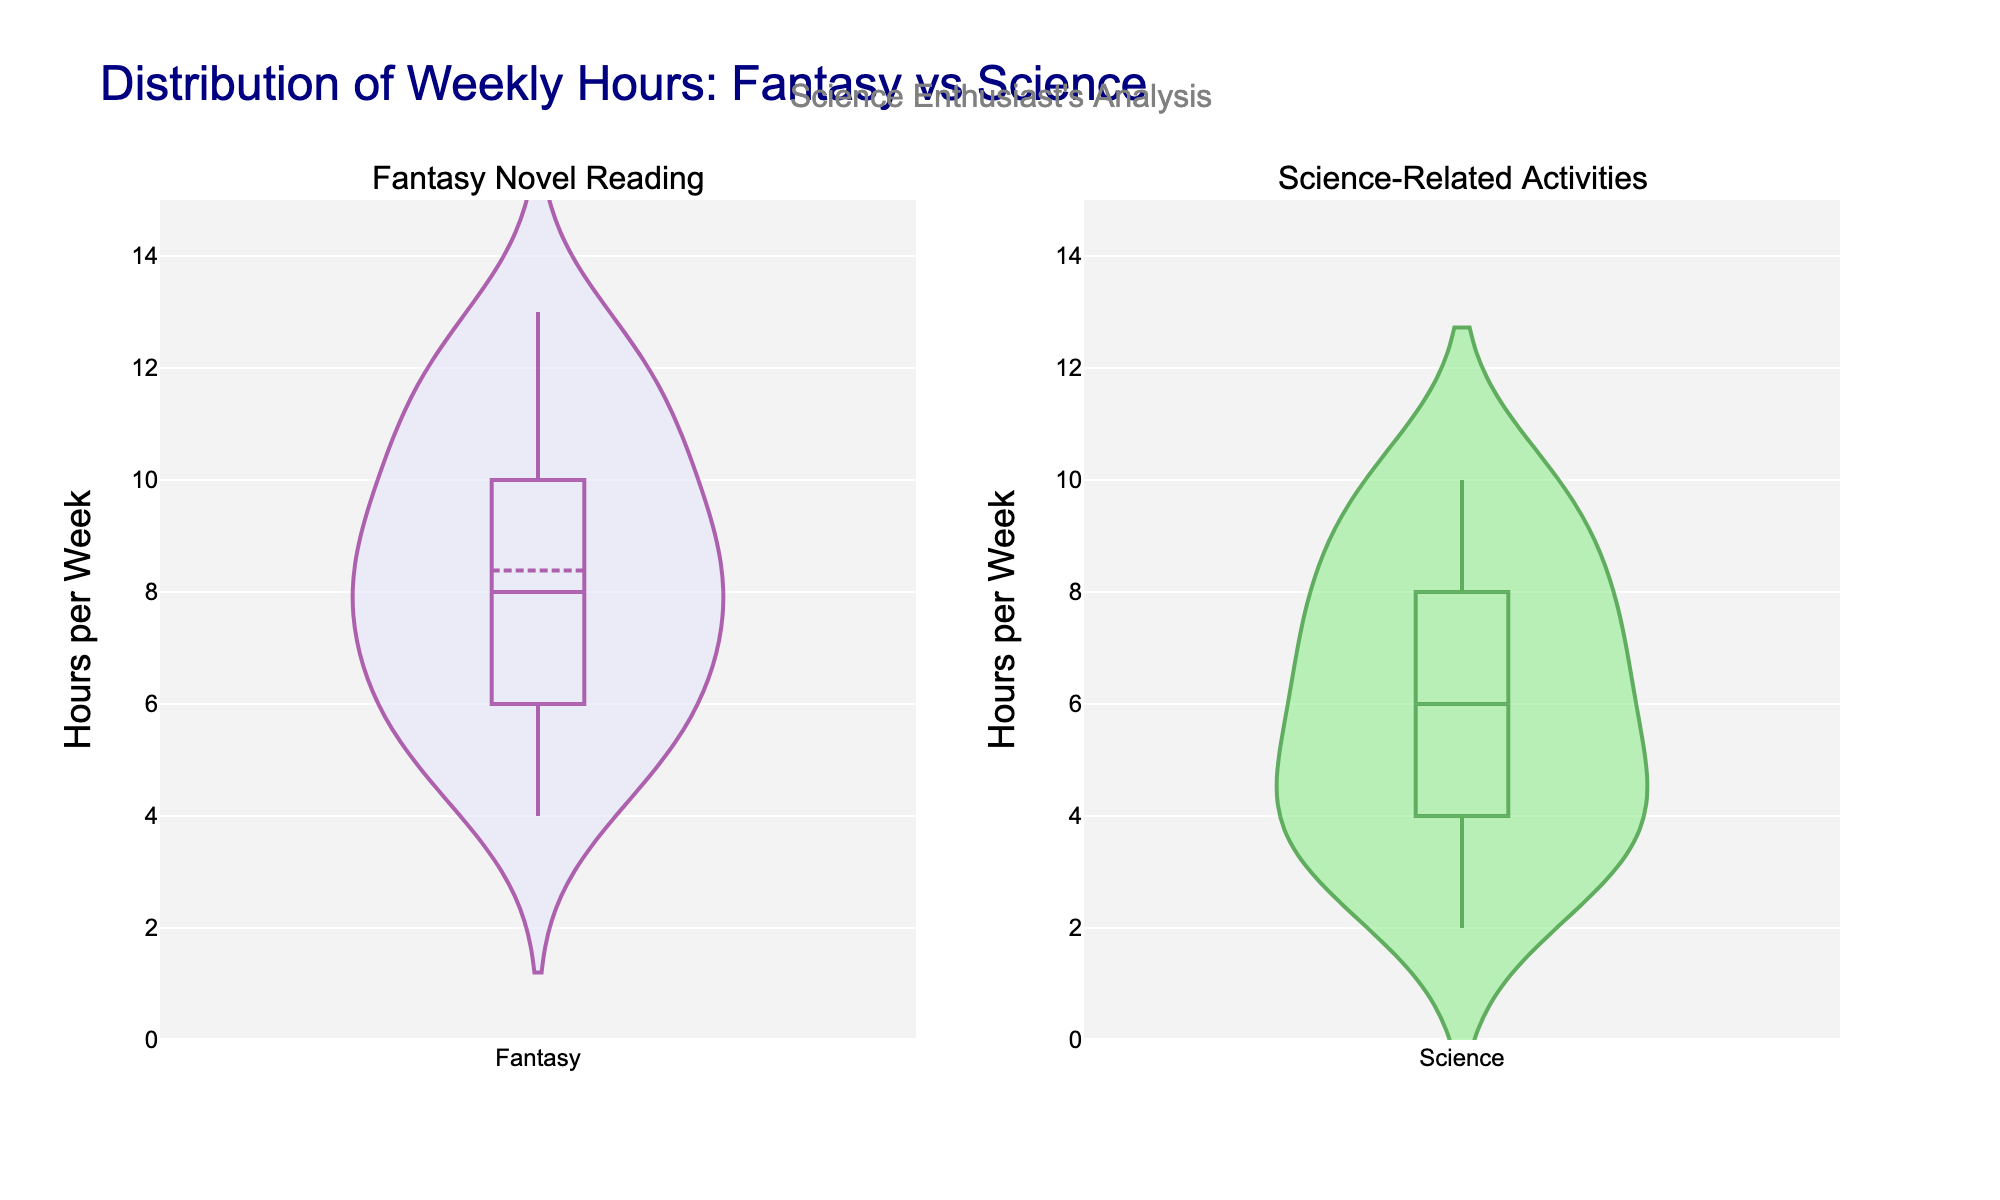What is the title of the figure? The title of the figure is located at the top of the plot and summarizes the overall content of the figure.
Answer: Distribution of Weekly Hours: Fantasy vs Science What do the colors represent on the violin plots? The colors differentiate the two categories being compared. The purple color represents Fantasy Novel Reading, and the green color represents Science-Related Activities.
Answer: Fantasy is purple, Science is green How many hours per week do most students spend on science-related activities? The thickness of the violin plot at various points indicates the distribution of the data. The plot for Science-Related Activities is thickest around a particular range, suggesting where most data points fall.
Answer: Around 6-7 hours Which category has a broader distribution of weekly hours? A broader distribution is indicated by a more spread-out shape of the violin plot. Compare the spread of the violin plot for Fantasy Novel Reading and Science-Related Activities.
Answer: Fantasy Novel Reading What is the median weekly hours spent on reading fantasy novels? The median is indicated by a horizontal line inside the box of the violin plot. Locate the horizontal line in the Fantasy violin plot.
Answer: 9 hours Are there more outliers in weekly hours for science-related activities or fantasy novel reading? Outliers are data points that fall significantly outside the main distribution and are often shown as individual points or have a significant distance from the center of the violin plot. Compare the outliers in both categories.
Answer: Science-Related Activities What is the range of hours spent on reading fantasy novels? The range can be determined by the vertical extent of the violin plot for the Fantasy category, from the lowest to the highest data point.
Answer: 4 to 13 hours Is the mean weekly hours spent on science-related activities higher or lower than the mean for fantasy novel reading? The mean is indicated by a central line within the filling of the violin plot. Compare the mean lines of both categories.
Answer: Lower Which activity shows a higher variability in the weekly hours spent by students? Variability can be inferred from the width and spread of the violin plot. A wider and less symmetric plot indicates higher variability.
Answer: Fantasy Novel Reading How does the time spent on science activities compare to fantasy reading in terms of having more students at the low end of the distribution? Compare the thickness of the lower part of each violin plot to determine where more students spend fewer hours.
Answer: More students spend fewer hours on Science 